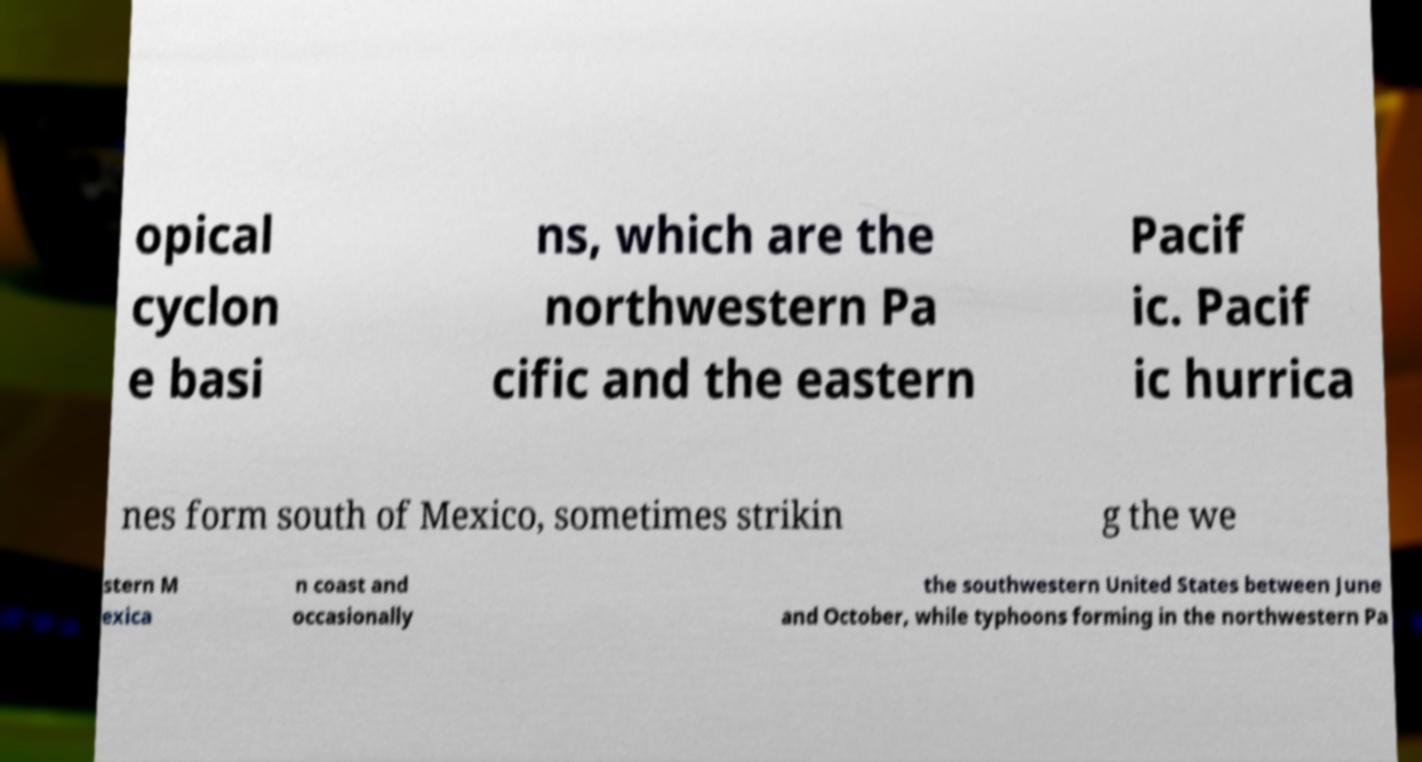I need the written content from this picture converted into text. Can you do that? opical cyclon e basi ns, which are the northwestern Pa cific and the eastern Pacif ic. Pacif ic hurrica nes form south of Mexico, sometimes strikin g the we stern M exica n coast and occasionally the southwestern United States between June and October, while typhoons forming in the northwestern Pa 